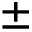Convert formula to latex. <formula><loc_0><loc_0><loc_500><loc_500>\pm</formula> 